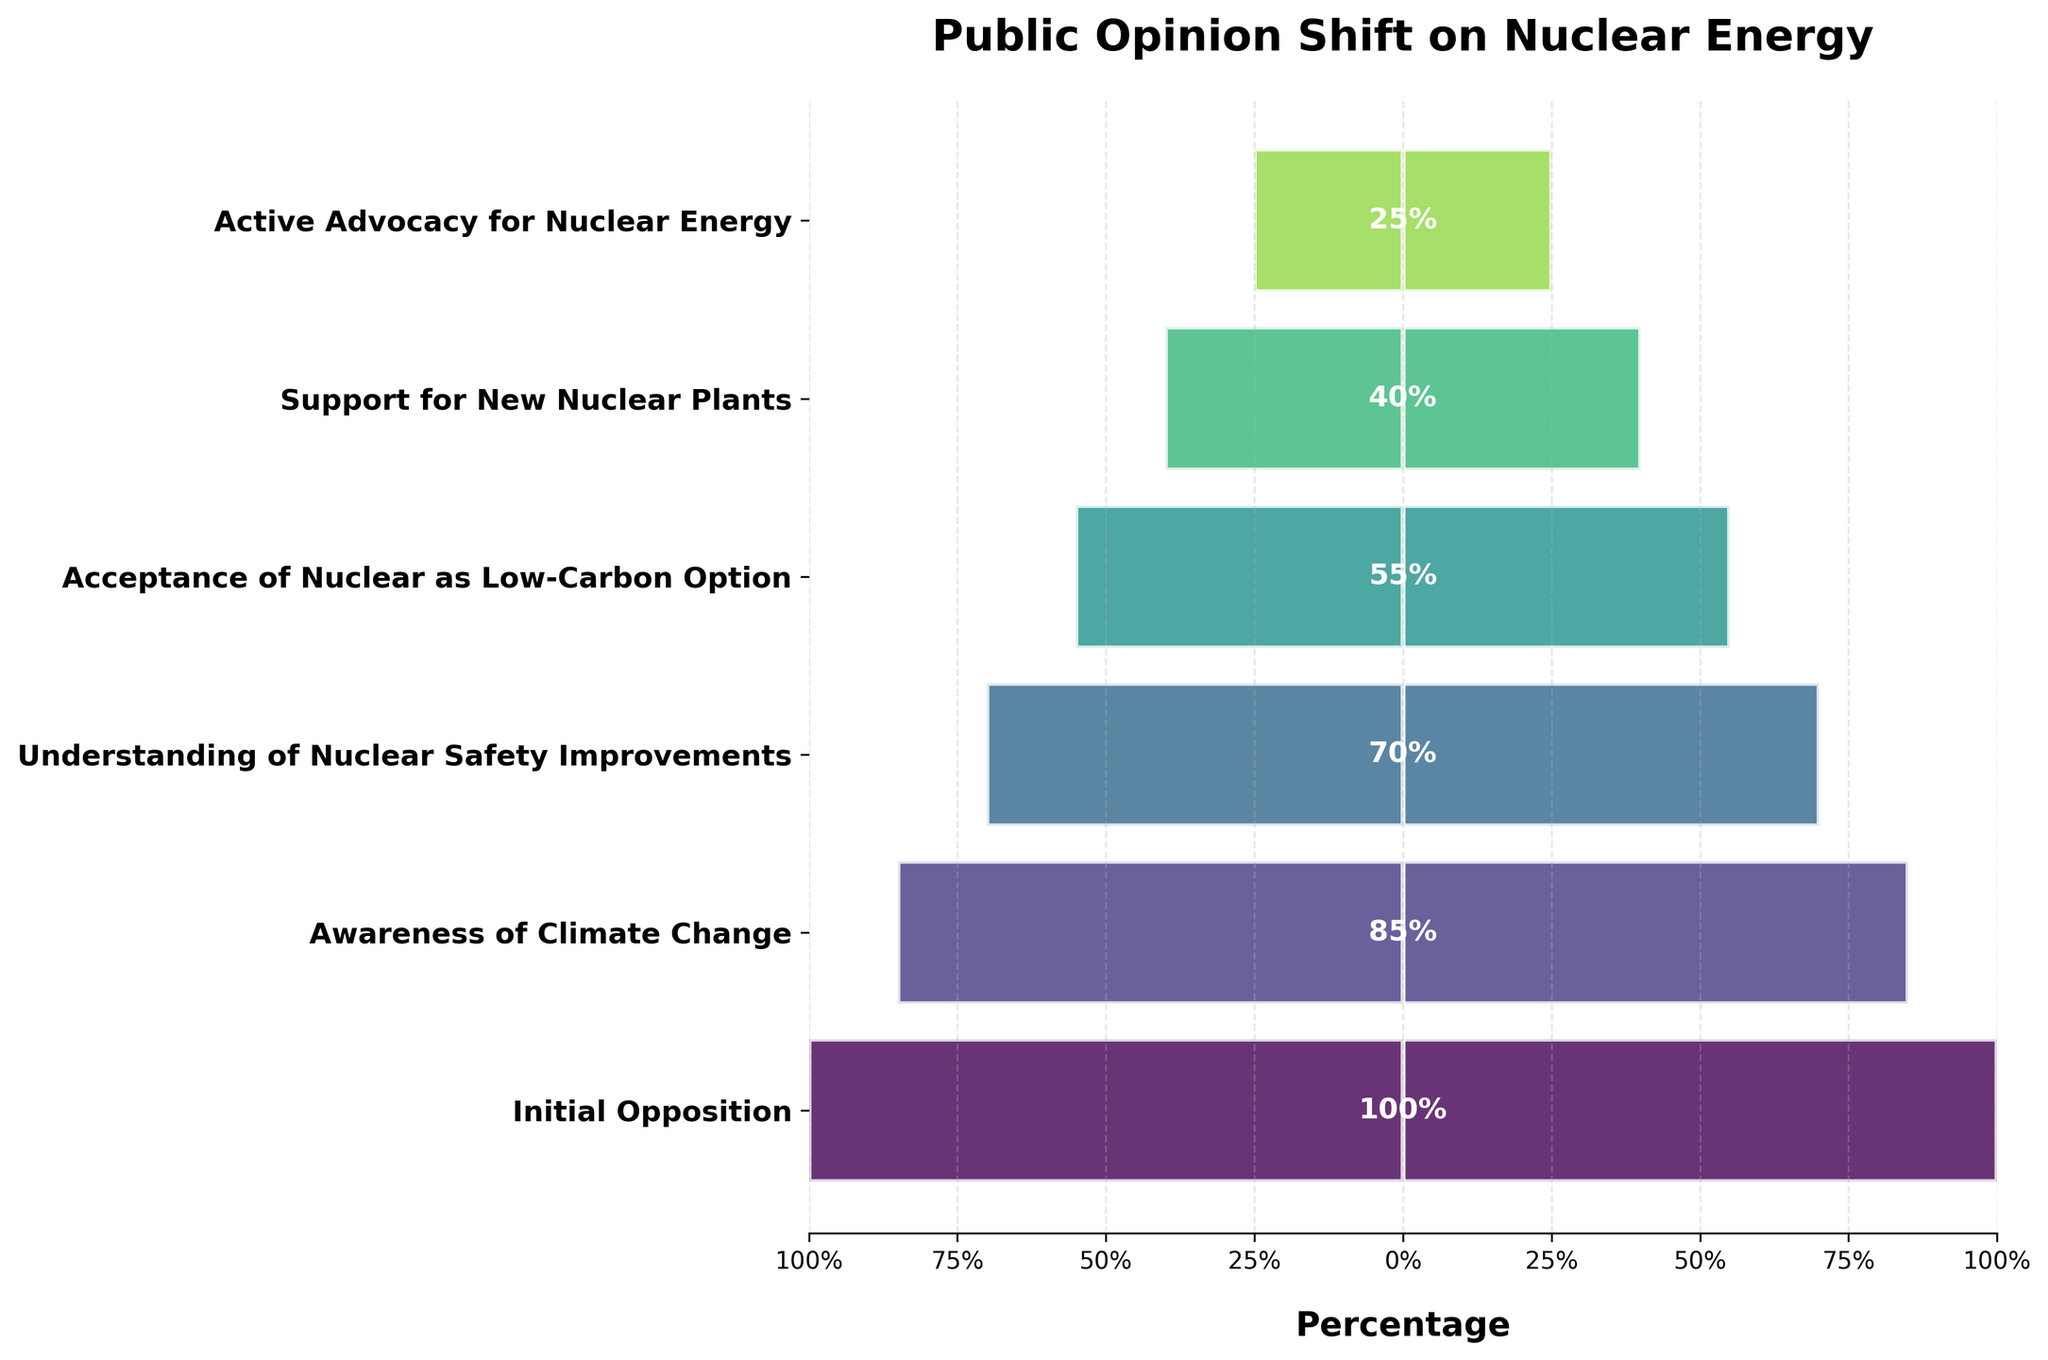What is the title of the funnel chart? The title of the chart can be found at the top of the figure.
Answer: Public Opinion Shift on Nuclear Energy How many stages are shown in the funnel chart? Count the number of distinct labels on the y-axis.
Answer: Six At which stage does public opposition drop to 70%? Identify the stage label associated with the 70% value.
Answer: Understanding of Nuclear Safety Improvements What is the percentage drop from 'Awareness of Climate Change' to 'Understanding of Nuclear Safety Improvements'? Subtract the percentage value of 'Understanding of Nuclear Safety Improvements' from 'Awareness of Climate Change'.
Answer: 15% Which stage shows a 40% support for nuclear energy? Identify the stage label associated with the 40% value.
Answer: Support for New Nuclear Plants Compare the percentage of public support between the 'Acceptance of Nuclear as Low-Carbon Option' and 'Support for New Nuclear Plants'. Read the percentages for both stages and compare them. 'Acceptance of Nuclear as Low-Carbon Option' is at 55%, and 'Support for New Nuclear Plants' is at 40%. 55% is greater than 40%.
Answer: Acceptance of Nuclear as Low-Carbon Option has higher support What is the average percentage change per stage from 'Initial Opposition' to 'Active Advocacy for Nuclear Energy'? Calculate the average of the differences in percentages from one stage to the next. Differences are (100-85), (85-70), (70-55), (55-40), (40-25). Add them up and divide by the number of stages minus one (5 stages). (15+15+15+15+15)/5=15.
Answer: 15% Which stage shows the least amount of public support for nuclear energy? Identify the stage with the lowest percentage value.
Answer: Active Advocacy for Nuclear Energy How much does the percentage decrease from the 'Initial Opposition' to 'Active Advocacy for Nuclear Energy'? Subtract the percentage value of 'Active Advocacy for Nuclear Energy' from 'Initial Opposition'.
Answer: 75% Which stage indicates the transition where the public begins supporting new nuclear plants? Identify the stage labeled with '40%'.
Answer: Support for New Nuclear Plants Is the decrease in public opposition consistent across each stage? Calculate the percentage drop between each stage and determine if they are uniform. The drops are 15% at each stage.
Answer: Yes 